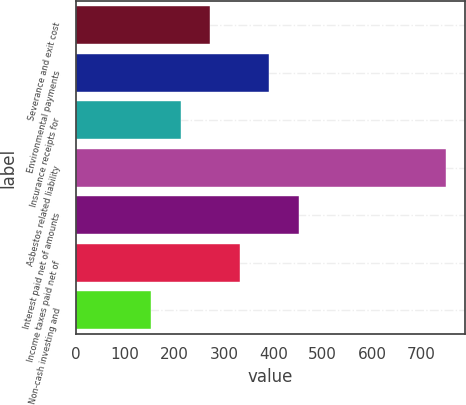Convert chart. <chart><loc_0><loc_0><loc_500><loc_500><bar_chart><fcel>Severance and exit cost<fcel>Environmental payments<fcel>Insurance receipts for<fcel>Asbestos related liability<fcel>Interest paid net of amounts<fcel>Income taxes paid net of<fcel>Non-cash investing and<nl><fcel>272.4<fcel>391.8<fcel>212.7<fcel>750<fcel>451.5<fcel>332.1<fcel>153<nl></chart> 